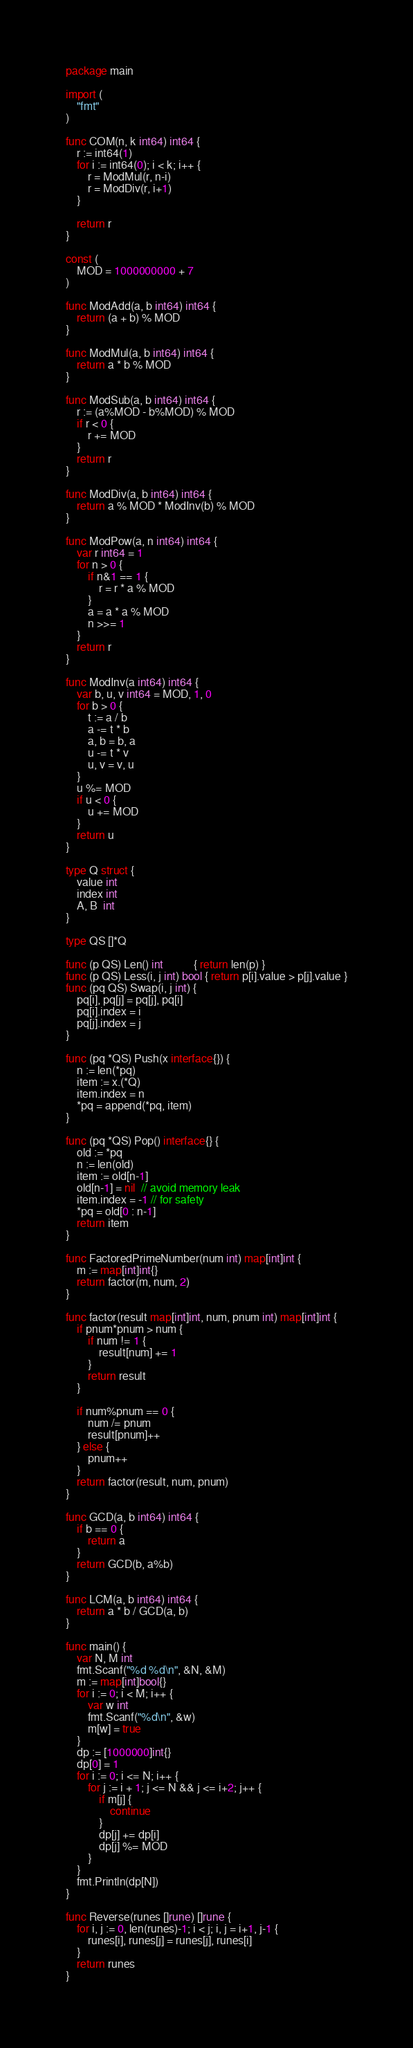<code> <loc_0><loc_0><loc_500><loc_500><_Go_>package main

import (
	"fmt"
)

func COM(n, k int64) int64 {
	r := int64(1)
	for i := int64(0); i < k; i++ {
		r = ModMul(r, n-i)
		r = ModDiv(r, i+1)
	}

	return r
}

const (
	MOD = 1000000000 + 7
)

func ModAdd(a, b int64) int64 {
	return (a + b) % MOD
}

func ModMul(a, b int64) int64 {
	return a * b % MOD
}

func ModSub(a, b int64) int64 {
	r := (a%MOD - b%MOD) % MOD
	if r < 0 {
		r += MOD
	}
	return r
}

func ModDiv(a, b int64) int64 {
	return a % MOD * ModInv(b) % MOD
}

func ModPow(a, n int64) int64 {
	var r int64 = 1
	for n > 0 {
		if n&1 == 1 {
			r = r * a % MOD
		}
		a = a * a % MOD
		n >>= 1
	}
	return r
}

func ModInv(a int64) int64 {
	var b, u, v int64 = MOD, 1, 0
	for b > 0 {
		t := a / b
		a -= t * b
		a, b = b, a
		u -= t * v
		u, v = v, u
	}
	u %= MOD
	if u < 0 {
		u += MOD
	}
	return u
}

type Q struct {
	value int
	index int
	A, B  int
}

type QS []*Q

func (p QS) Len() int           { return len(p) }
func (p QS) Less(i, j int) bool { return p[i].value > p[j].value }
func (pq QS) Swap(i, j int) {
	pq[i], pq[j] = pq[j], pq[i]
	pq[i].index = i
	pq[j].index = j
}

func (pq *QS) Push(x interface{}) {
	n := len(*pq)
	item := x.(*Q)
	item.index = n
	*pq = append(*pq, item)
}

func (pq *QS) Pop() interface{} {
	old := *pq
	n := len(old)
	item := old[n-1]
	old[n-1] = nil  // avoid memory leak
	item.index = -1 // for safety
	*pq = old[0 : n-1]
	return item
}

func FactoredPrimeNumber(num int) map[int]int {
	m := map[int]int{}
	return factor(m, num, 2)
}

func factor(result map[int]int, num, pnum int) map[int]int {
	if pnum*pnum > num {
		if num != 1 {
			result[num] += 1
		}
		return result
	}

	if num%pnum == 0 {
		num /= pnum
		result[pnum]++
	} else {
		pnum++
	}
	return factor(result, num, pnum)
}

func GCD(a, b int64) int64 {
	if b == 0 {
		return a
	}
	return GCD(b, a%b)
}

func LCM(a, b int64) int64 {
	return a * b / GCD(a, b)
}

func main() {
	var N, M int
	fmt.Scanf("%d %d\n", &N, &M)
	m := map[int]bool{}
	for i := 0; i < M; i++ {
		var w int
		fmt.Scanf("%d\n", &w)
		m[w] = true
	}
	dp := [1000000]int{}
	dp[0] = 1
	for i := 0; i <= N; i++ {
		for j := i + 1; j <= N && j <= i+2; j++ {
			if m[j] {
				continue
			}
			dp[j] += dp[i]
			dp[j] %= MOD
		}
	}
	fmt.Println(dp[N])
}

func Reverse(runes []rune) []rune {
	for i, j := 0, len(runes)-1; i < j; i, j = i+1, j-1 {
		runes[i], runes[j] = runes[j], runes[i]
	}
	return runes
}
</code> 